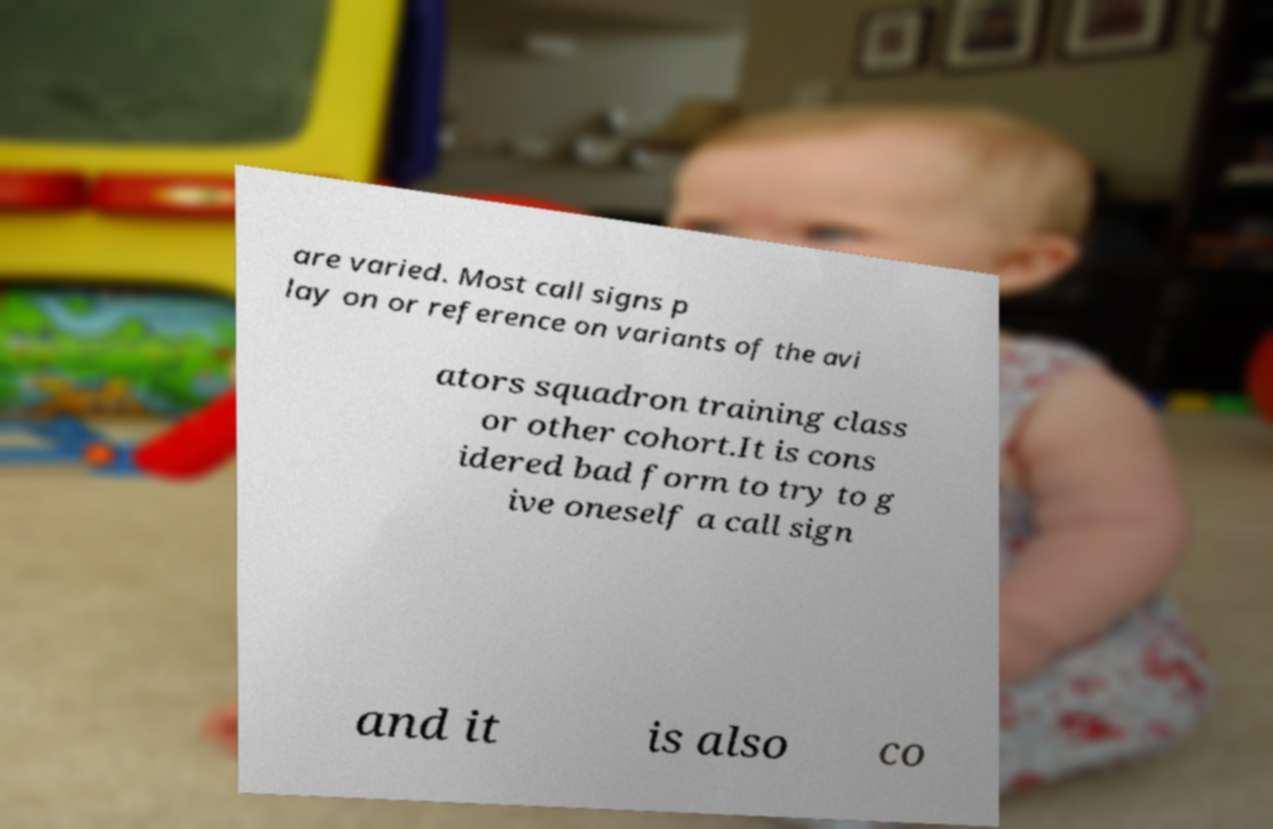Could you assist in decoding the text presented in this image and type it out clearly? are varied. Most call signs p lay on or reference on variants of the avi ators squadron training class or other cohort.It is cons idered bad form to try to g ive oneself a call sign and it is also co 